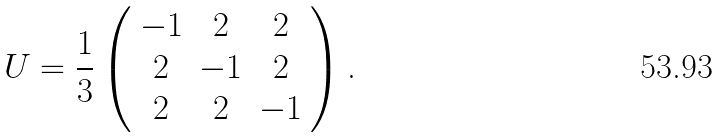Convert formula to latex. <formula><loc_0><loc_0><loc_500><loc_500>U = \frac { 1 } { 3 } \left ( \begin{array} { c c c } - 1 & 2 & 2 \\ 2 & - 1 & 2 \\ 2 & 2 & - 1 \end{array} \right ) \text {.}</formula> 